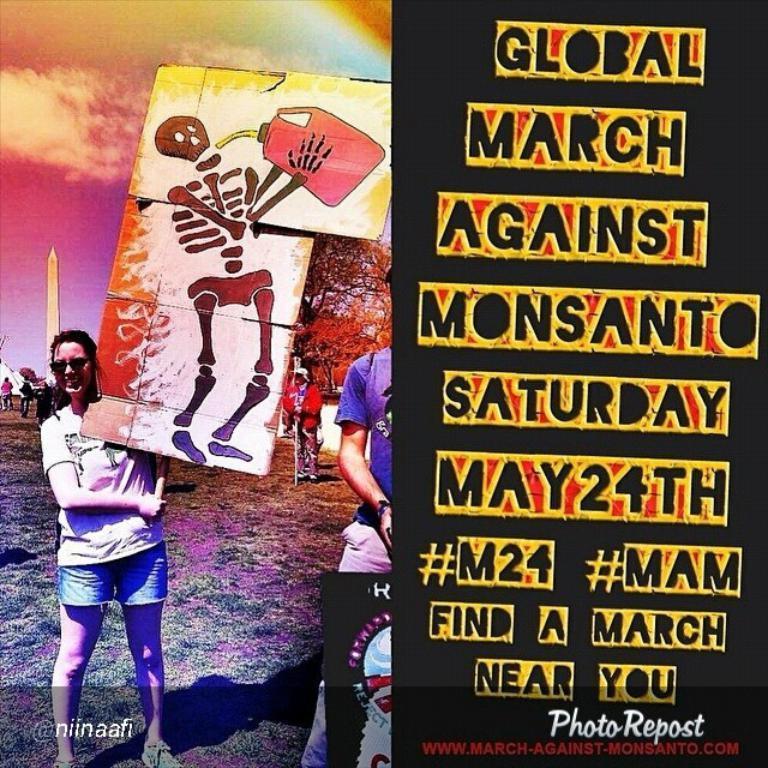Describe this image in one or two sentences. In the picture I can see a poster in which I can see a person wearing white color T-shirt is holding a board and standing on the ground. In the background, I can see trees, tower, a few more people walking on the grass and I can see the sky with clouds. Here I can see some text on the black background and it is on the right side of the image. Here I can see the watermark on the bottom left side of the image. 